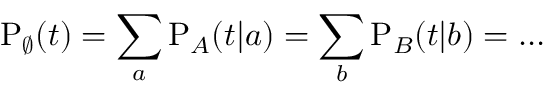<formula> <loc_0><loc_0><loc_500><loc_500>P _ { \varnothing } ( t ) = \sum _ { a } P _ { A } ( t | a ) = \sum _ { b } P _ { B } ( t | b ) = \dots</formula> 